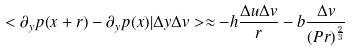Convert formula to latex. <formula><loc_0><loc_0><loc_500><loc_500>< \partial _ { y } p ( x + r ) - \partial _ { y } p ( x ) | \Delta y \Delta v > \approx - h \frac { \Delta u \Delta v } { r } - b \frac { \Delta v } { ( P r ) ^ { \frac { 2 } { 3 } } }</formula> 